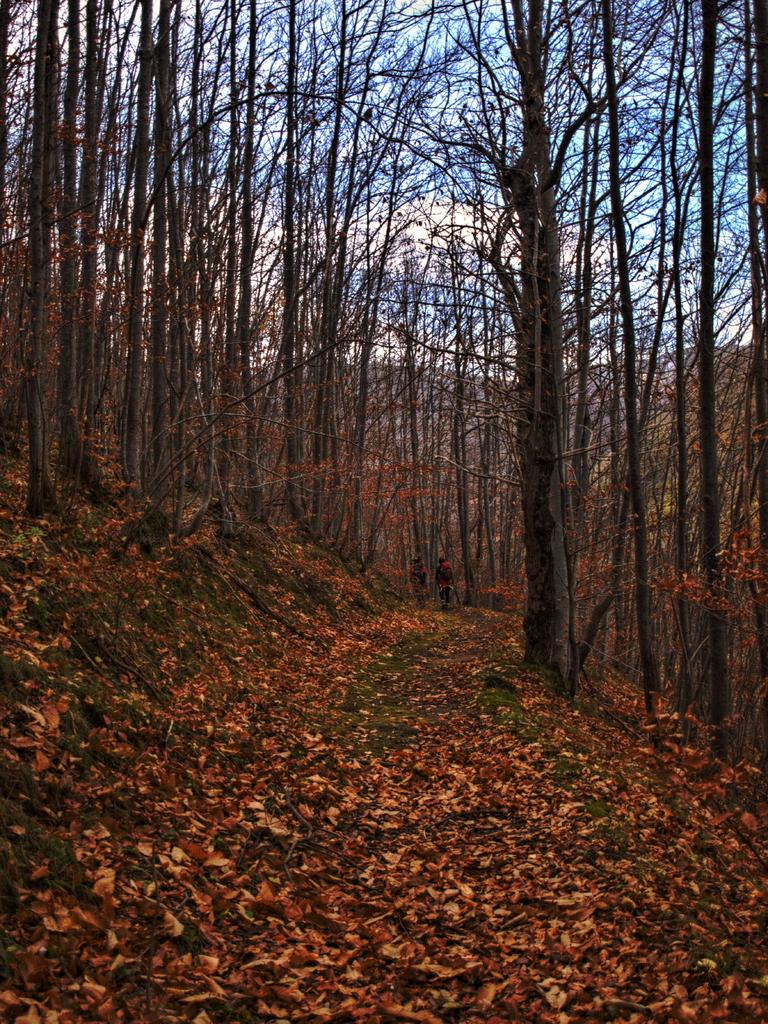What type of vegetation can be seen in the image? There are trees with branches and leaves in the image. What geographical feature is depicted in the image? The image appears to depict a hill. What can be found on the ground in the image? Dried leaves are lying on the ground in the image. What type of pencil is being used by the creator in the image? There is no creator or pencil present in the image. Can you tell me how many donkeys are grazing on the hill in the image? There are no donkeys present in the image; it only depicts trees, a hill, and dried leaves on the ground. 